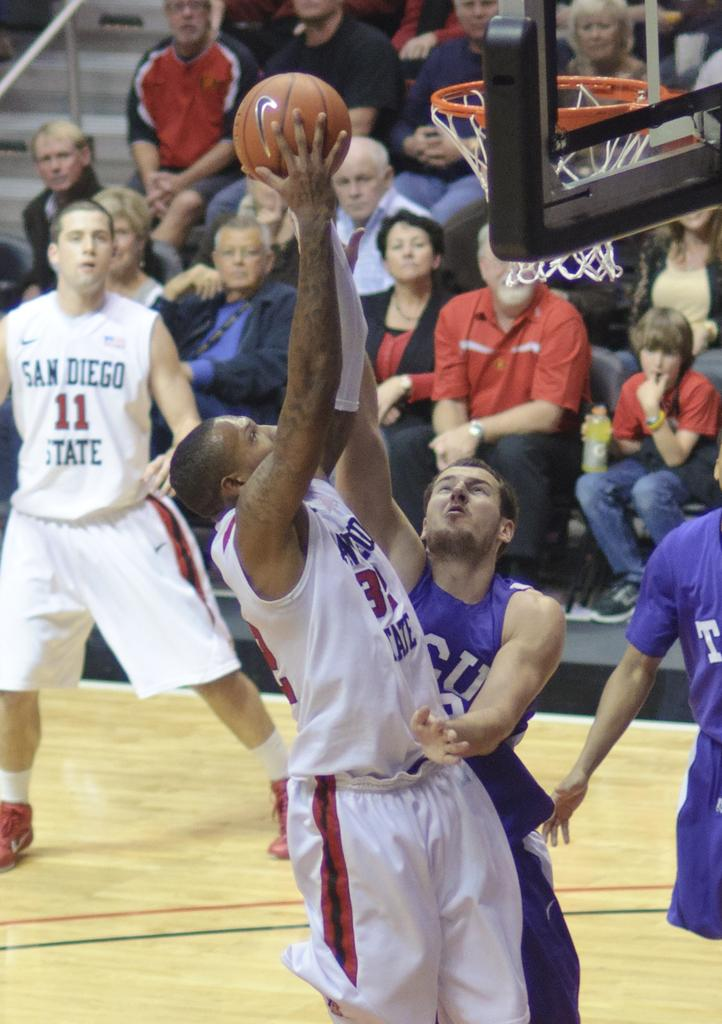What activity are the people in the image engaged in? The people in the image are playing with a ball. Are there any spectators in the image? Yes, there are many people sitting and watching the game. What type of committee is meeting in the image? There is no committee meeting in the image; it features people playing with a ball and spectators watching the game. 